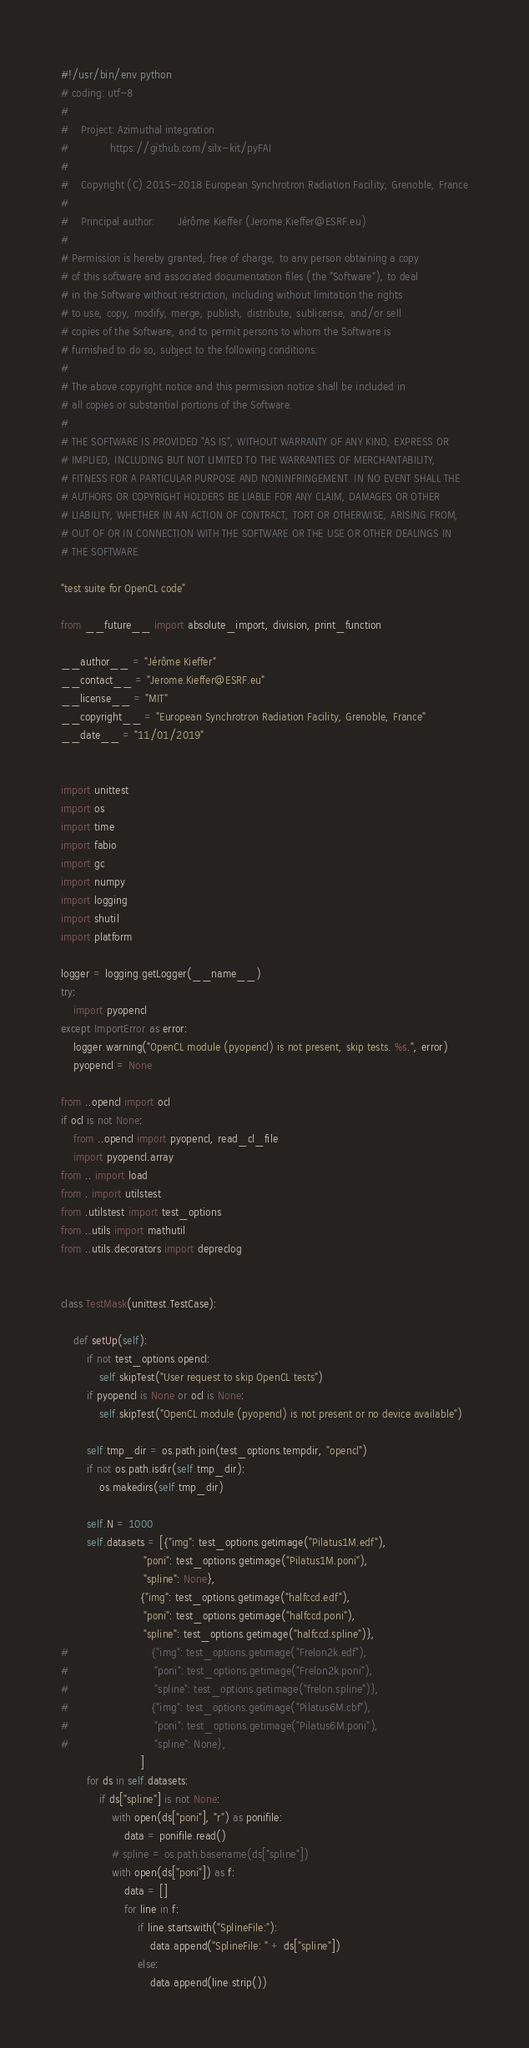Convert code to text. <code><loc_0><loc_0><loc_500><loc_500><_Python_>#!/usr/bin/env python
# coding: utf-8
#
#    Project: Azimuthal integration
#             https://github.com/silx-kit/pyFAI
#
#    Copyright (C) 2015-2018 European Synchrotron Radiation Facility, Grenoble, France
#
#    Principal author:       Jérôme Kieffer (Jerome.Kieffer@ESRF.eu)
#
# Permission is hereby granted, free of charge, to any person obtaining a copy
# of this software and associated documentation files (the "Software"), to deal
# in the Software without restriction, including without limitation the rights
# to use, copy, modify, merge, publish, distribute, sublicense, and/or sell
# copies of the Software, and to permit persons to whom the Software is
# furnished to do so, subject to the following conditions:
#
# The above copyright notice and this permission notice shall be included in
# all copies or substantial portions of the Software.
#
# THE SOFTWARE IS PROVIDED "AS IS", WITHOUT WARRANTY OF ANY KIND, EXPRESS OR
# IMPLIED, INCLUDING BUT NOT LIMITED TO THE WARRANTIES OF MERCHANTABILITY,
# FITNESS FOR A PARTICULAR PURPOSE AND NONINFRINGEMENT. IN NO EVENT SHALL THE
# AUTHORS OR COPYRIGHT HOLDERS BE LIABLE FOR ANY CLAIM, DAMAGES OR OTHER
# LIABILITY, WHETHER IN AN ACTION OF CONTRACT, TORT OR OTHERWISE, ARISING FROM,
# OUT OF OR IN CONNECTION WITH THE SOFTWARE OR THE USE OR OTHER DEALINGS IN
# THE SOFTWARE.

"test suite for OpenCL code"

from __future__ import absolute_import, division, print_function

__author__ = "Jérôme Kieffer"
__contact__ = "Jerome.Kieffer@ESRF.eu"
__license__ = "MIT"
__copyright__ = "European Synchrotron Radiation Facility, Grenoble, France"
__date__ = "11/01/2019"


import unittest
import os
import time
import fabio
import gc
import numpy
import logging
import shutil
import platform

logger = logging.getLogger(__name__)
try:
    import pyopencl
except ImportError as error:
    logger.warning("OpenCL module (pyopencl) is not present, skip tests. %s.", error)
    pyopencl = None

from ..opencl import ocl
if ocl is not None:
    from ..opencl import pyopencl, read_cl_file
    import pyopencl.array
from .. import load
from . import utilstest
from .utilstest import test_options
from ..utils import mathutil
from ..utils.decorators import depreclog


class TestMask(unittest.TestCase):

    def setUp(self):
        if not test_options.opencl:
            self.skipTest("User request to skip OpenCL tests")
        if pyopencl is None or ocl is None:
            self.skipTest("OpenCL module (pyopencl) is not present or no device available")

        self.tmp_dir = os.path.join(test_options.tempdir, "opencl")
        if not os.path.isdir(self.tmp_dir):
            os.makedirs(self.tmp_dir)

        self.N = 1000
        self.datasets = [{"img": test_options.getimage("Pilatus1M.edf"),
                          "poni": test_options.getimage("Pilatus1M.poni"),
                          "spline": None},
                         {"img": test_options.getimage("halfccd.edf"),
                          "poni": test_options.getimage("halfccd.poni"),
                          "spline": test_options.getimage("halfccd.spline")},
#                          {"img": test_options.getimage("Frelon2k.edf"),
#                           "poni": test_options.getimage("Frelon2k.poni"),
#                           "spline": test_options.getimage("frelon.spline")},
#                          {"img": test_options.getimage("Pilatus6M.cbf"),
#                           "poni": test_options.getimage("Pilatus6M.poni"),
#                           "spline": None},
                         ]
        for ds in self.datasets:
            if ds["spline"] is not None:
                with open(ds["poni"], "r") as ponifile:
                    data = ponifile.read()
                # spline = os.path.basename(ds["spline"])
                with open(ds["poni"]) as f:
                    data = []
                    for line in f:
                        if line.startswith("SplineFile:"):
                            data.append("SplineFile: " + ds["spline"])
                        else:
                            data.append(line.strip())</code> 